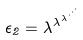<formula> <loc_0><loc_0><loc_500><loc_500>\epsilon _ { 2 } = \lambda ^ { \lambda ^ { \lambda ^ { \cdot ^ { \cdot ^ { \cdot } } } } }</formula> 